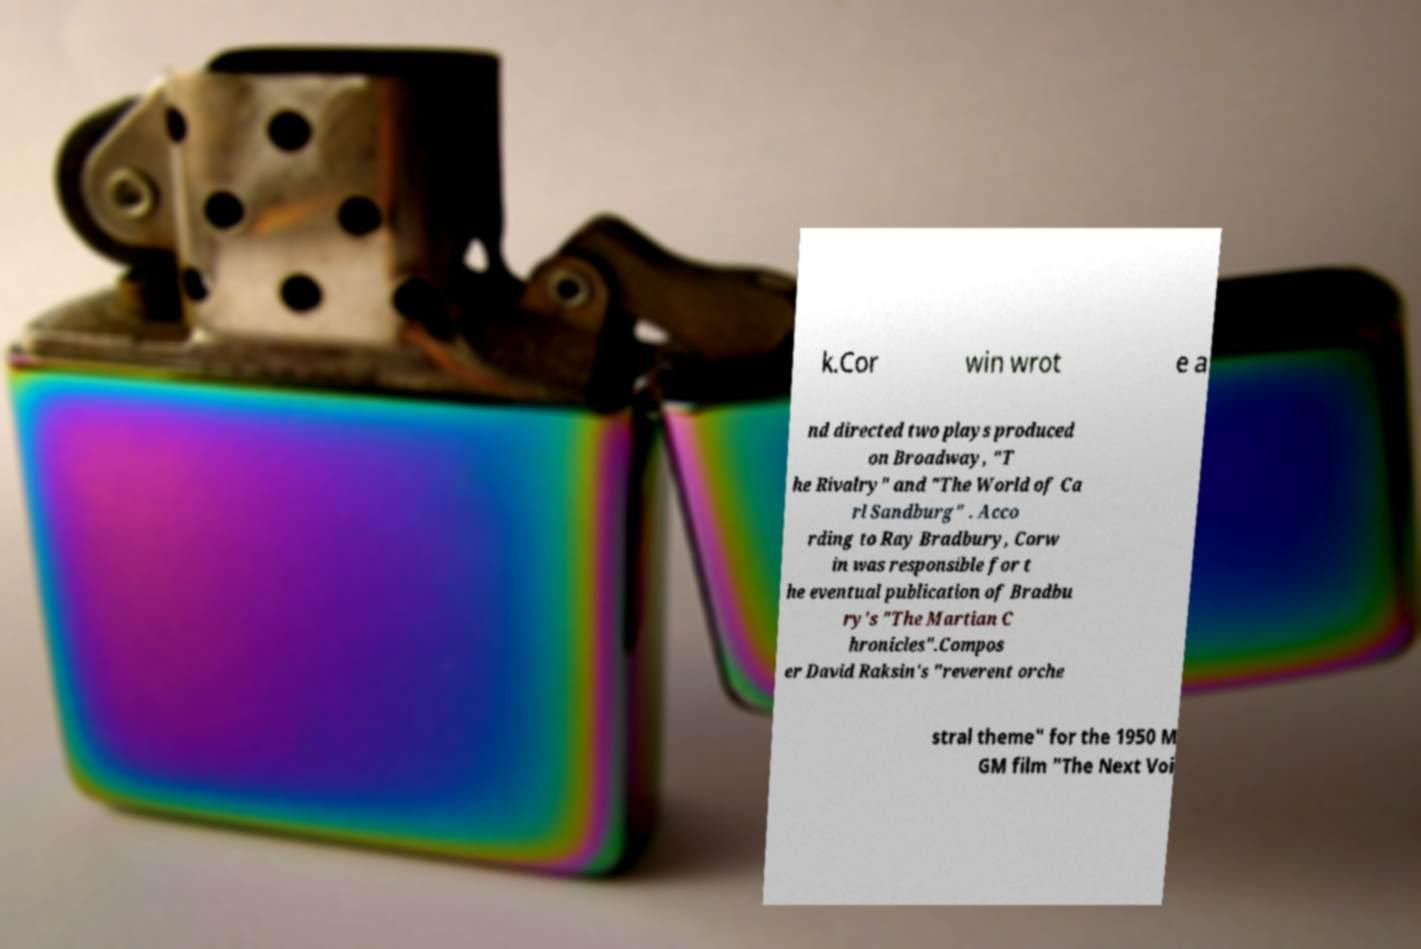What messages or text are displayed in this image? I need them in a readable, typed format. k.Cor win wrot e a nd directed two plays produced on Broadway, "T he Rivalry" and "The World of Ca rl Sandburg" . Acco rding to Ray Bradbury, Corw in was responsible for t he eventual publication of Bradbu ry's "The Martian C hronicles".Compos er David Raksin's "reverent orche stral theme" for the 1950 M GM film "The Next Voi 